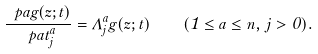<formula> <loc_0><loc_0><loc_500><loc_500>\frac { \ p a g ( z ; t ) } { \ p a t _ { j } ^ { a } } = \Lambda _ { j } ^ { a } g ( z ; t ) \quad ( 1 \leq a \leq n , \, j > 0 ) .</formula> 